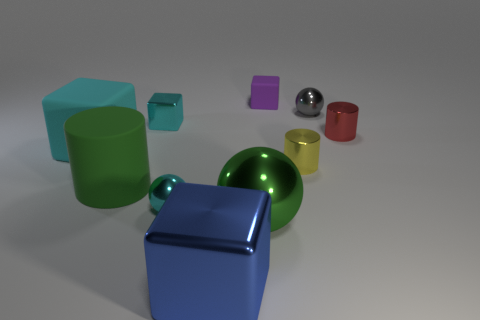How many objects are there of each color? In the image, there are two green objects, one blue object, one purple object, one silver object, one yellow object, and one red object. 